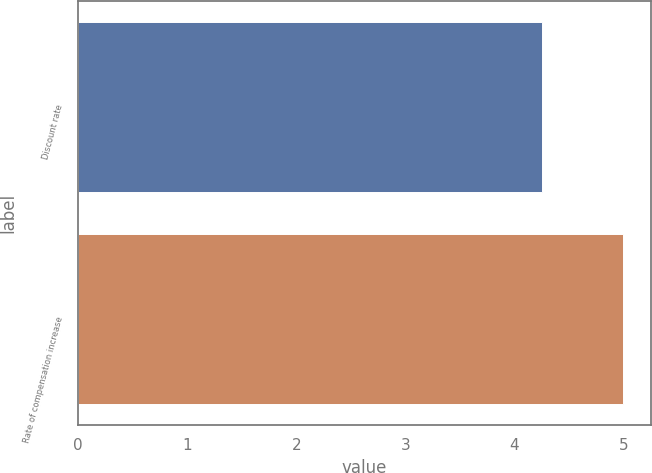Convert chart. <chart><loc_0><loc_0><loc_500><loc_500><bar_chart><fcel>Discount rate<fcel>Rate of compensation increase<nl><fcel>4.25<fcel>5<nl></chart> 